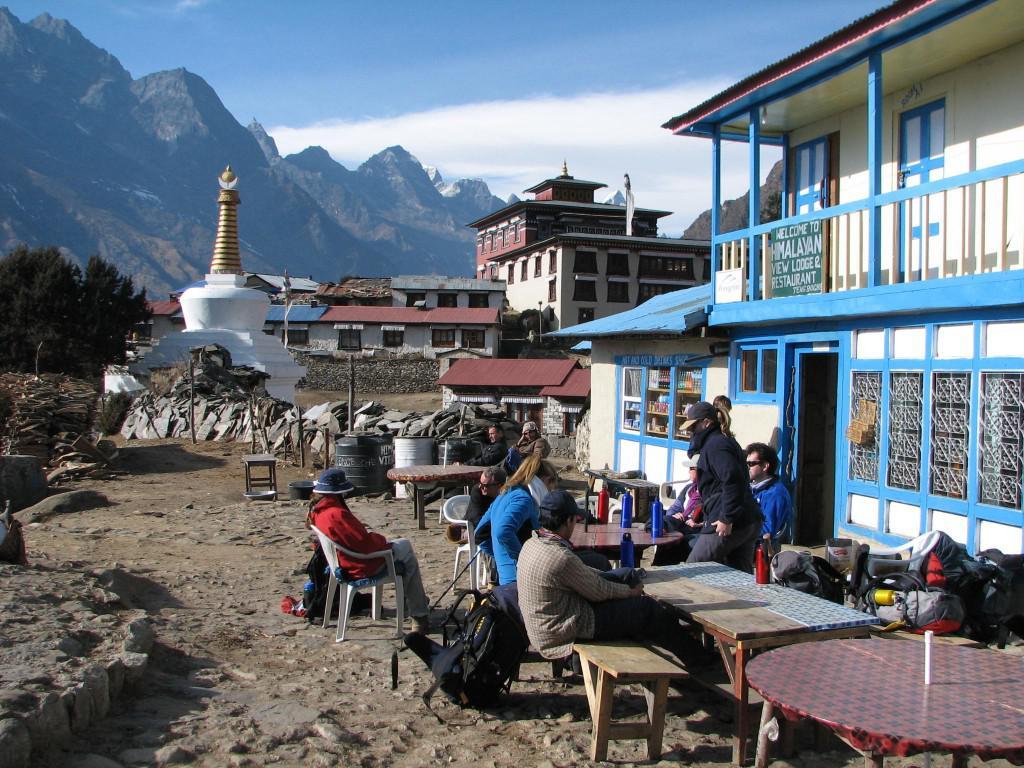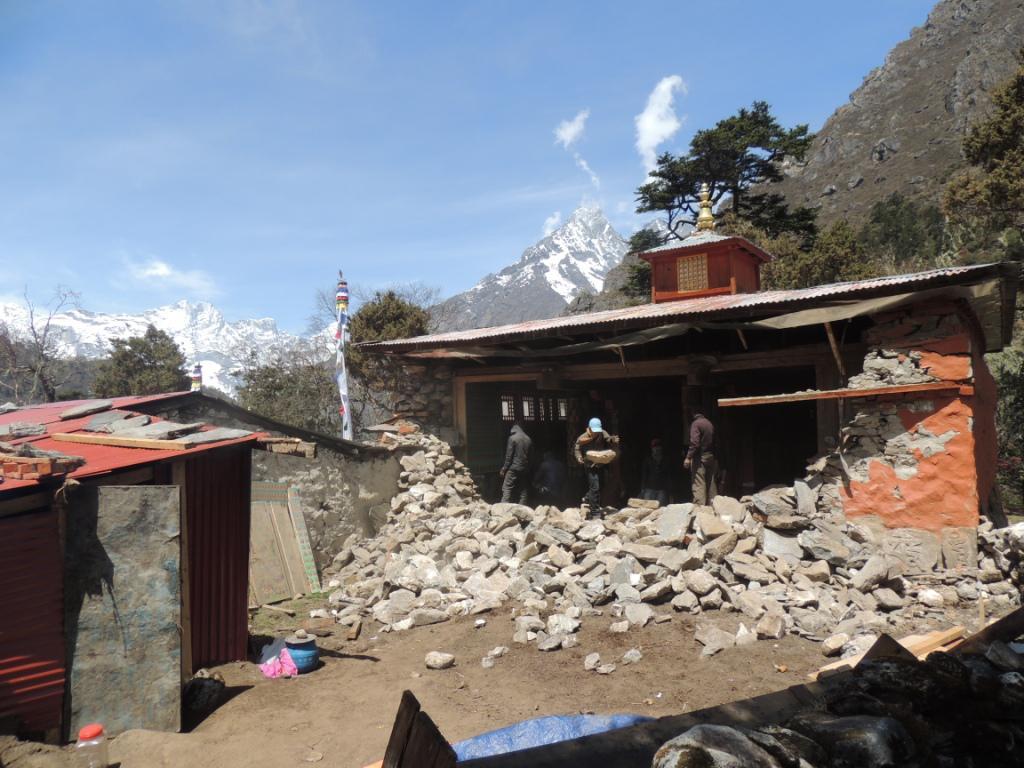The first image is the image on the left, the second image is the image on the right. Evaluate the accuracy of this statement regarding the images: "In the right image, a neutral colored building with at least eight windows on its front is on a hillside with mountains in the background.". Is it true? Answer yes or no. No. The first image is the image on the left, the second image is the image on the right. Considering the images on both sides, is "People are standing outside of the building in the image on the right." valid? Answer yes or no. Yes. 